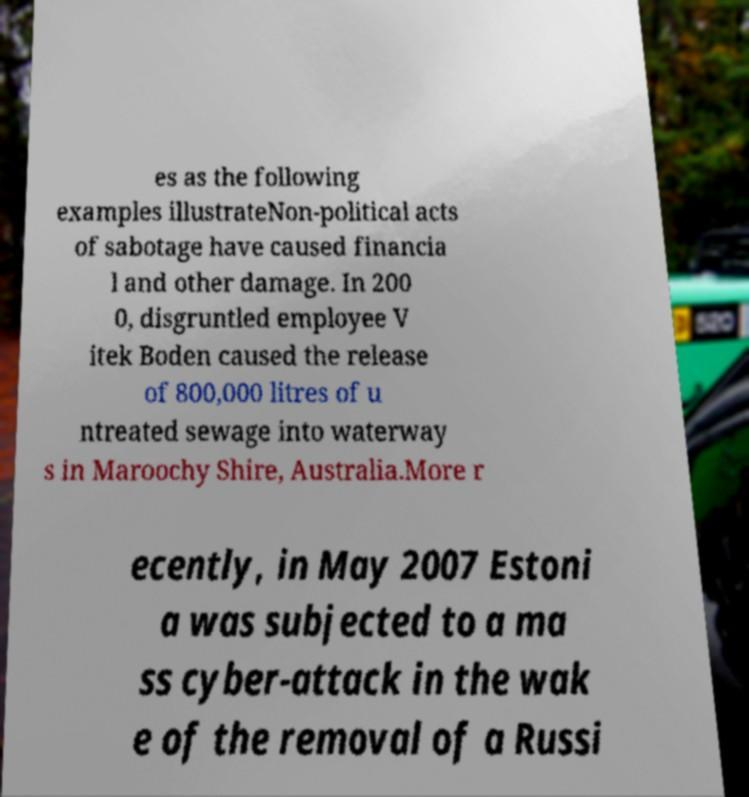What messages or text are displayed in this image? I need them in a readable, typed format. es as the following examples illustrateNon-political acts of sabotage have caused financia l and other damage. In 200 0, disgruntled employee V itek Boden caused the release of 800,000 litres of u ntreated sewage into waterway s in Maroochy Shire, Australia.More r ecently, in May 2007 Estoni a was subjected to a ma ss cyber-attack in the wak e of the removal of a Russi 